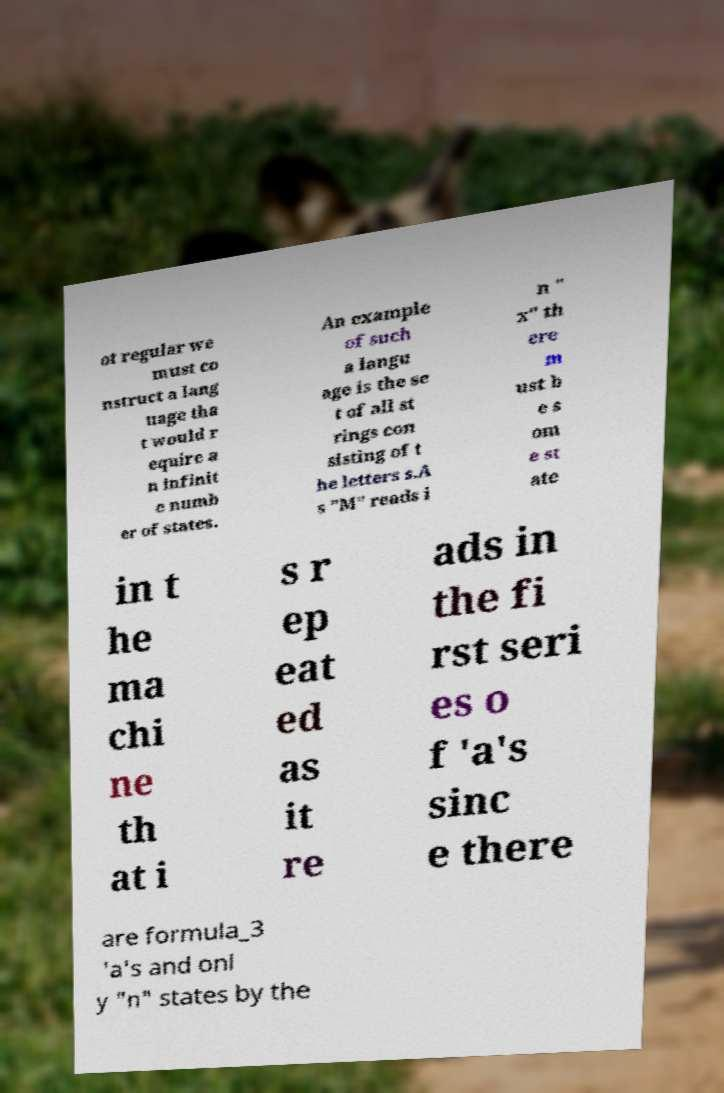What messages or text are displayed in this image? I need them in a readable, typed format. ot regular we must co nstruct a lang uage tha t would r equire a n infinit e numb er of states. An example of such a langu age is the se t of all st rings con sisting of t he letters s.A s "M" reads i n " x" th ere m ust b e s om e st ate in t he ma chi ne th at i s r ep eat ed as it re ads in the fi rst seri es o f 'a's sinc e there are formula_3 'a's and onl y "n" states by the 